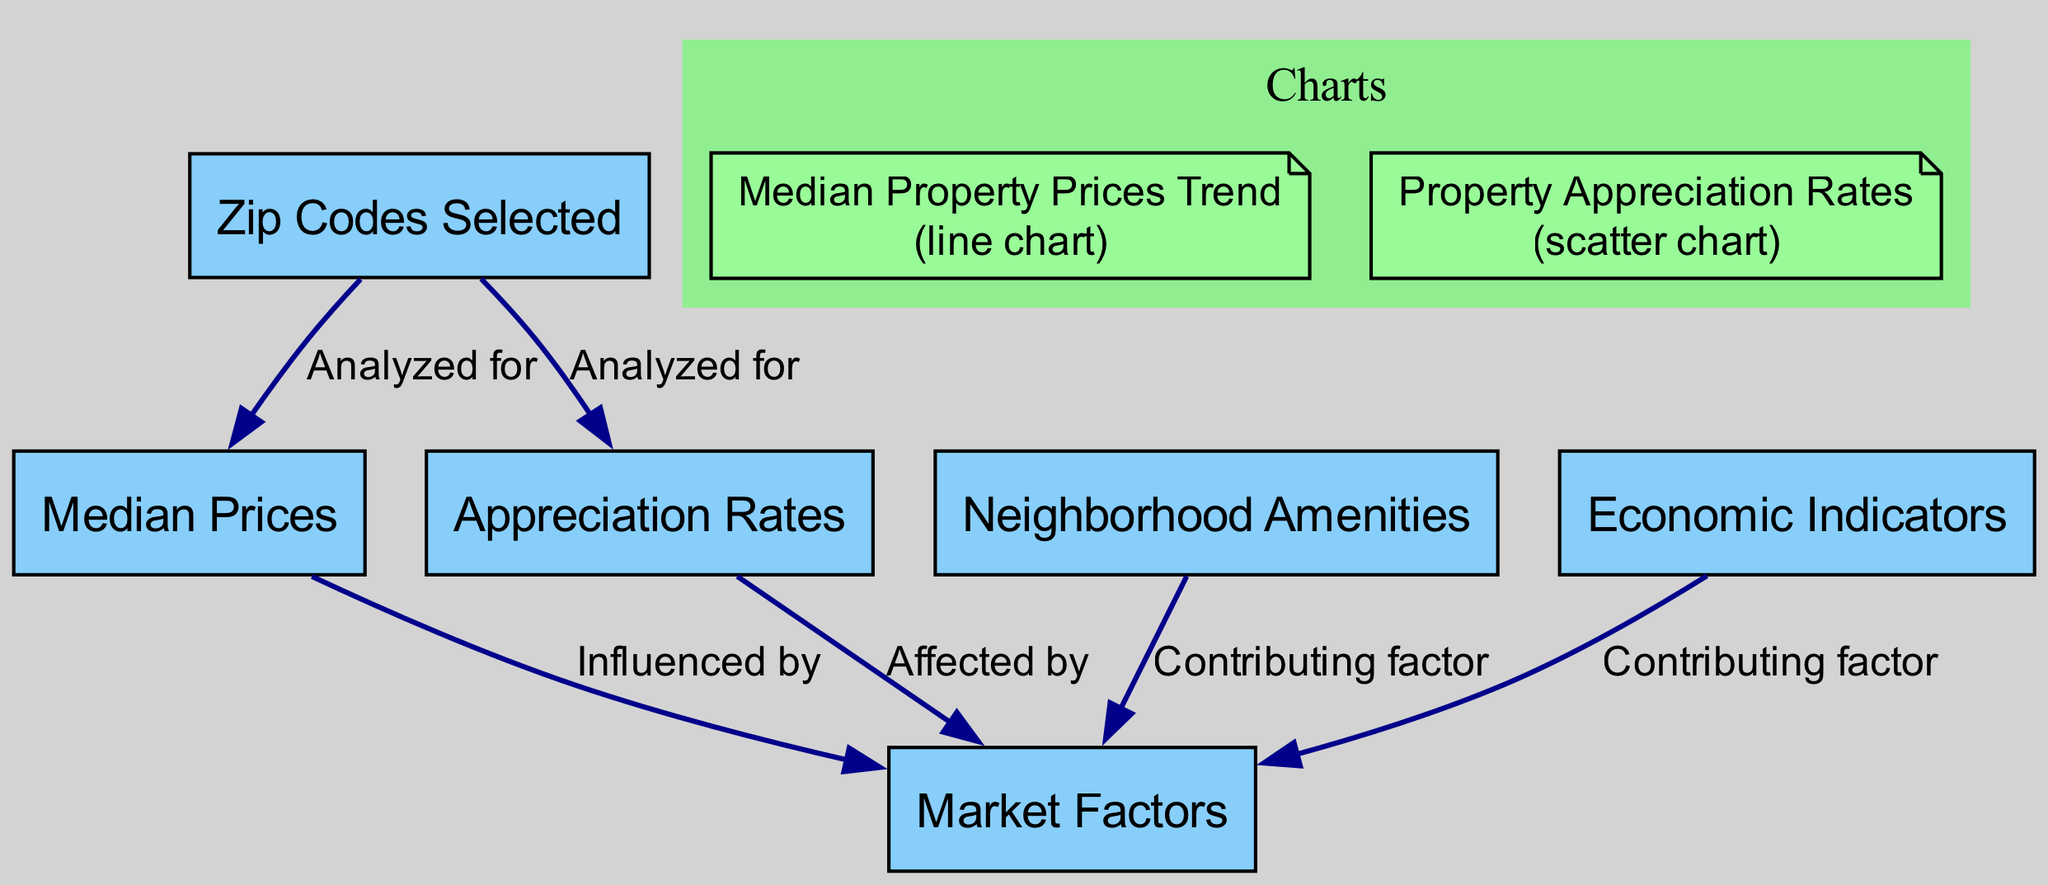What are the nodes in the diagram? The diagram contains six nodes representing different aspects of property value analysis, including "Median Prices," "Appreciation Rates," "Market Factors," "Zip Codes Selected," "Neighborhood Amenities," and "Economic Indicators."
Answer: Six What relationship exists between "Zip Codes Selected" and "Median Prices"? The diagram indicates that "Zip Codes Selected" is analyzed for "Median Prices," suggesting a direct connection where the median prices are evaluated based on the selected zip codes.
Answer: Analyzed for What type of chart is used to display median property prices? The diagram specifically states that a line chart is used to compare median property prices across the selected zip codes over time.
Answer: Line chart How many contributing factors influence market factors according to the diagram? The diagram shows two contributing factors, which are "Neighborhood Amenities" and "Economic Indicators" that influence the trends in the market factors.
Answer: Two What is the primary focus of the diagram? The primary focus of the diagram is to showcase the comparative analysis of property values across various zip codes, emphasizing median prices, appreciation rates, and contributing market factors.
Answer: Comparative analysis of property values How do the economic indicators relate to market factors? The diagram indicates that "Economic Indicators" are a contributing factor that affects "Market Factors," implying a causal relationship where economic conditions influence property values.
Answer: Contributing factor What are the different types of graphs presented in the diagram? There are two types of graphs presented in the diagram: a line graph for median property prices and a scatter plot for property appreciation rates, each serving to visualize different data aspects.
Answer: Line graph and scatter plot Which node influences both median prices and appreciation rates? The diagram illustrates that "Market Factors" influences both "Median Prices" and "Appreciation Rates," establishing it as a central node affecting these elements.
Answer: Market Factors What summary information does the "Market Factors" node contain? The "Market Factors" node summarizes key factors that influence property value trends, including neighborhood amenities and economic indicators, encapsulating the aspects affecting the market.
Answer: Key factors influencing property value trends 